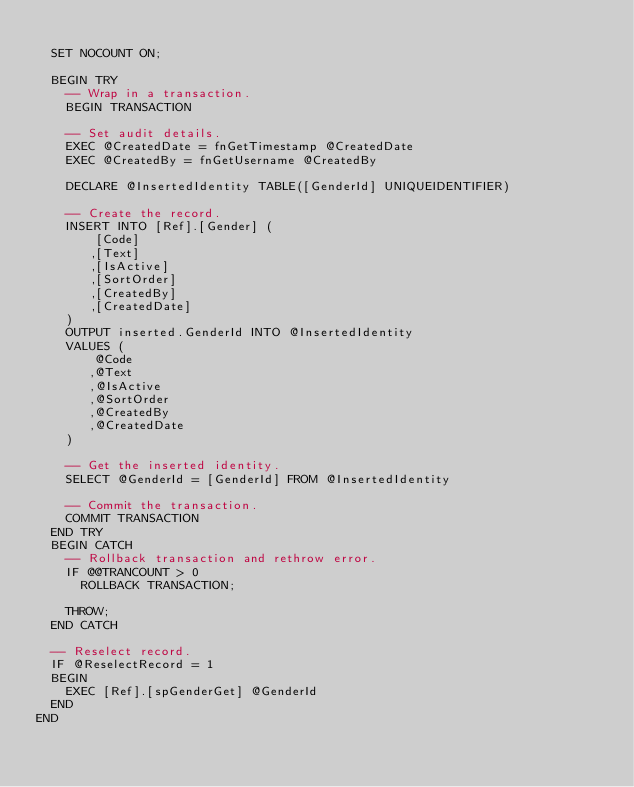Convert code to text. <code><loc_0><loc_0><loc_500><loc_500><_SQL_> 
  SET NOCOUNT ON;
  
  BEGIN TRY
    -- Wrap in a transaction.
    BEGIN TRANSACTION

    -- Set audit details.
    EXEC @CreatedDate = fnGetTimestamp @CreatedDate
    EXEC @CreatedBy = fnGetUsername @CreatedBy

    DECLARE @InsertedIdentity TABLE([GenderId] UNIQUEIDENTIFIER)

    -- Create the record.
    INSERT INTO [Ref].[Gender] (
        [Code]
       ,[Text]
       ,[IsActive]
       ,[SortOrder]
       ,[CreatedBy]
       ,[CreatedDate]
    )
    OUTPUT inserted.GenderId INTO @InsertedIdentity
    VALUES (
        @Code
       ,@Text
       ,@IsActive
       ,@SortOrder
       ,@CreatedBy
       ,@CreatedDate
    )

    -- Get the inserted identity.
    SELECT @GenderId = [GenderId] FROM @InsertedIdentity

    -- Commit the transaction.
    COMMIT TRANSACTION
  END TRY
  BEGIN CATCH
    -- Rollback transaction and rethrow error.
    IF @@TRANCOUNT > 0
      ROLLBACK TRANSACTION;

    THROW;
  END CATCH
  
  -- Reselect record.
  IF @ReselectRecord = 1
  BEGIN
    EXEC [Ref].[spGenderGet] @GenderId
  END
END</code> 